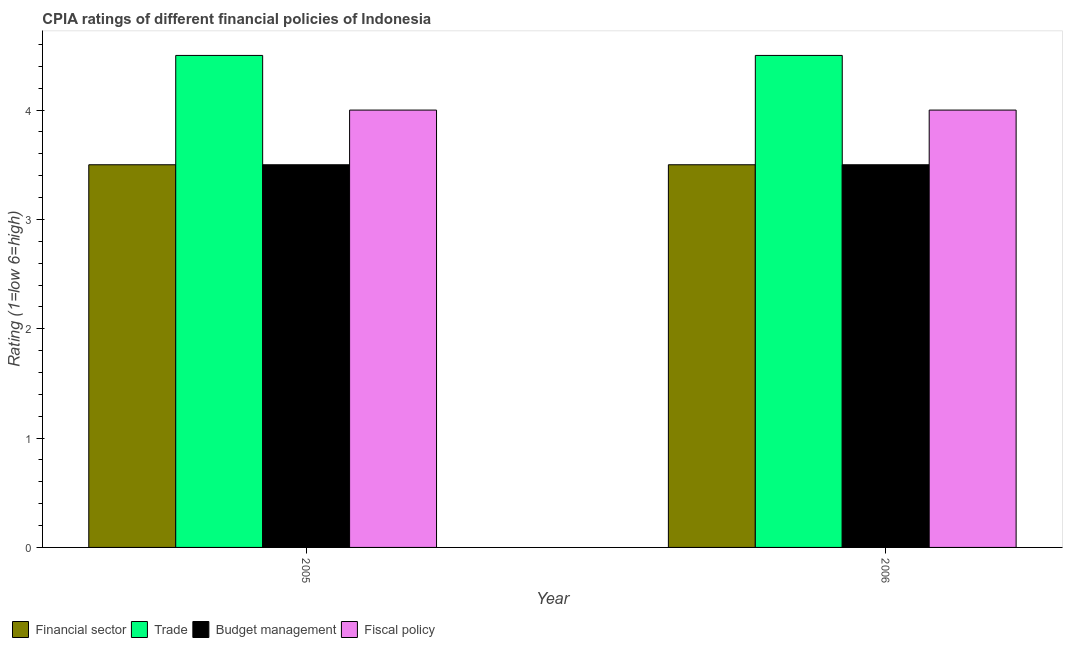Are the number of bars per tick equal to the number of legend labels?
Provide a short and direct response. Yes. Are the number of bars on each tick of the X-axis equal?
Ensure brevity in your answer.  Yes. Across all years, what is the maximum cpia rating of fiscal policy?
Provide a short and direct response. 4. In which year was the cpia rating of trade minimum?
Give a very brief answer. 2005. What is the total cpia rating of budget management in the graph?
Provide a succinct answer. 7. In how many years, is the cpia rating of trade greater than 0.2?
Your answer should be compact. 2. What is the ratio of the cpia rating of financial sector in 2005 to that in 2006?
Make the answer very short. 1. What does the 4th bar from the left in 2006 represents?
Your response must be concise. Fiscal policy. What does the 4th bar from the right in 2005 represents?
Make the answer very short. Financial sector. Is it the case that in every year, the sum of the cpia rating of financial sector and cpia rating of trade is greater than the cpia rating of budget management?
Keep it short and to the point. Yes. Are all the bars in the graph horizontal?
Provide a short and direct response. No. How many years are there in the graph?
Keep it short and to the point. 2. Does the graph contain grids?
Make the answer very short. No. Where does the legend appear in the graph?
Offer a very short reply. Bottom left. How many legend labels are there?
Your response must be concise. 4. How are the legend labels stacked?
Your answer should be very brief. Horizontal. What is the title of the graph?
Provide a succinct answer. CPIA ratings of different financial policies of Indonesia. What is the Rating (1=low 6=high) in Fiscal policy in 2005?
Offer a terse response. 4. Across all years, what is the maximum Rating (1=low 6=high) of Financial sector?
Your answer should be compact. 3.5. Across all years, what is the maximum Rating (1=low 6=high) in Trade?
Provide a short and direct response. 4.5. Across all years, what is the maximum Rating (1=low 6=high) in Budget management?
Your answer should be compact. 3.5. Across all years, what is the maximum Rating (1=low 6=high) in Fiscal policy?
Keep it short and to the point. 4. Across all years, what is the minimum Rating (1=low 6=high) in Budget management?
Ensure brevity in your answer.  3.5. Across all years, what is the minimum Rating (1=low 6=high) in Fiscal policy?
Give a very brief answer. 4. What is the total Rating (1=low 6=high) in Trade in the graph?
Provide a short and direct response. 9. What is the total Rating (1=low 6=high) in Fiscal policy in the graph?
Make the answer very short. 8. What is the difference between the Rating (1=low 6=high) in Financial sector in 2005 and that in 2006?
Ensure brevity in your answer.  0. What is the difference between the Rating (1=low 6=high) in Fiscal policy in 2005 and that in 2006?
Ensure brevity in your answer.  0. What is the difference between the Rating (1=low 6=high) in Financial sector in 2005 and the Rating (1=low 6=high) in Trade in 2006?
Offer a terse response. -1. What is the difference between the Rating (1=low 6=high) of Financial sector in 2005 and the Rating (1=low 6=high) of Budget management in 2006?
Make the answer very short. 0. What is the difference between the Rating (1=low 6=high) of Financial sector in 2005 and the Rating (1=low 6=high) of Fiscal policy in 2006?
Ensure brevity in your answer.  -0.5. What is the difference between the Rating (1=low 6=high) of Trade in 2005 and the Rating (1=low 6=high) of Budget management in 2006?
Offer a very short reply. 1. In the year 2005, what is the difference between the Rating (1=low 6=high) of Trade and Rating (1=low 6=high) of Budget management?
Provide a short and direct response. 1. In the year 2006, what is the difference between the Rating (1=low 6=high) in Financial sector and Rating (1=low 6=high) in Trade?
Keep it short and to the point. -1. In the year 2006, what is the difference between the Rating (1=low 6=high) of Trade and Rating (1=low 6=high) of Fiscal policy?
Offer a terse response. 0.5. In the year 2006, what is the difference between the Rating (1=low 6=high) of Budget management and Rating (1=low 6=high) of Fiscal policy?
Keep it short and to the point. -0.5. What is the ratio of the Rating (1=low 6=high) of Financial sector in 2005 to that in 2006?
Ensure brevity in your answer.  1. What is the ratio of the Rating (1=low 6=high) in Fiscal policy in 2005 to that in 2006?
Ensure brevity in your answer.  1. What is the difference between the highest and the second highest Rating (1=low 6=high) in Fiscal policy?
Keep it short and to the point. 0. What is the difference between the highest and the lowest Rating (1=low 6=high) in Financial sector?
Offer a terse response. 0. What is the difference between the highest and the lowest Rating (1=low 6=high) of Budget management?
Ensure brevity in your answer.  0. 